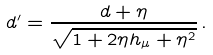Convert formula to latex. <formula><loc_0><loc_0><loc_500><loc_500>d ^ { \prime } = \frac { d + \eta } { \sqrt { 1 + 2 \eta h _ { \mu } + \eta ^ { 2 } } } \, .</formula> 